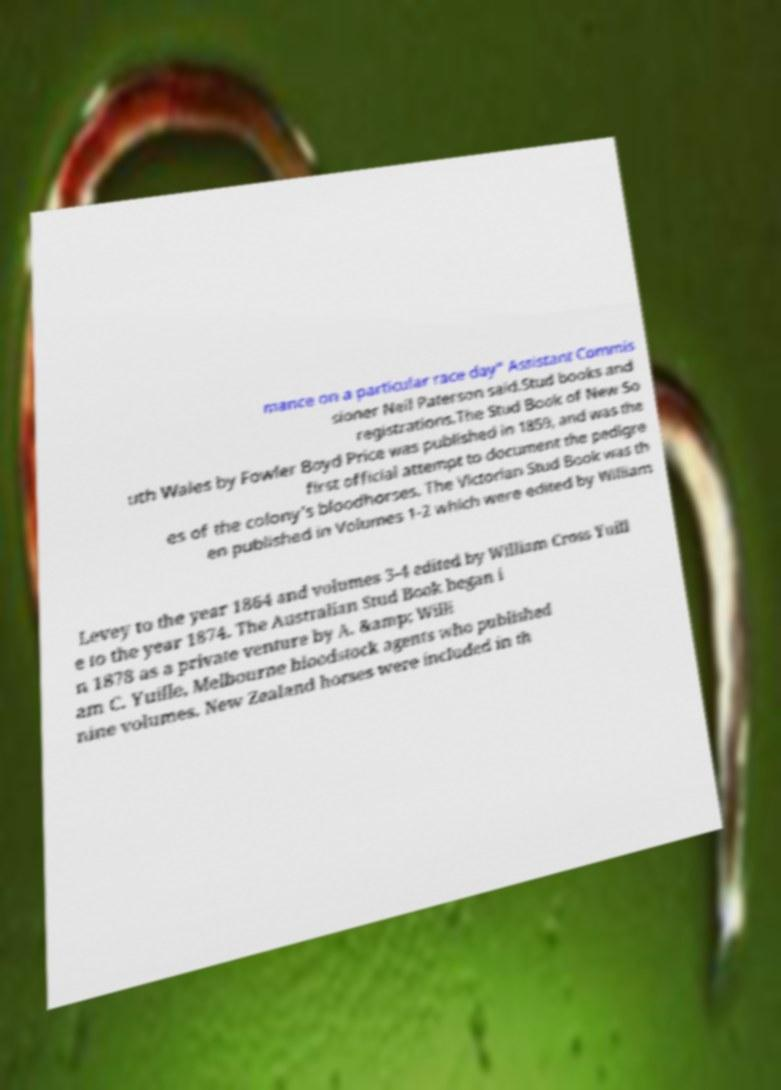Please read and relay the text visible in this image. What does it say? mance on a particular race day" Assistant Commis sioner Neil Paterson said.Stud books and registrations.The Stud Book of New So uth Wales by Fowler Boyd Price was published in 1859, and was the first official attempt to document the pedigre es of the colony's bloodhorses. The Victorian Stud Book was th en published in Volumes 1-2 which were edited by William Levey to the year 1864 and volumes 3-4 edited by William Cross Yuill e to the year 1874. The Australian Stud Book began i n 1878 as a private venture by A. &amp; Willi am C. Yuille, Melbourne bloodstock agents who published nine volumes. New Zealand horses were included in th 